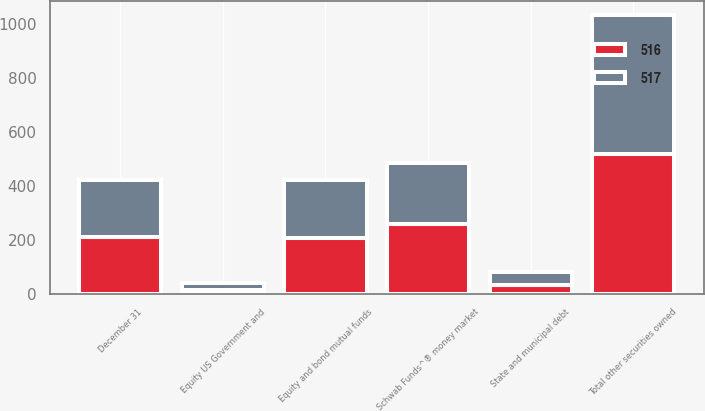<chart> <loc_0><loc_0><loc_500><loc_500><stacked_bar_chart><ecel><fcel>December 31<fcel>Schwab Funds^® money market<fcel>Equity and bond mutual funds<fcel>State and municipal debt<fcel>Equity US Government and<fcel>Total other securities owned<nl><fcel>517<fcel>211.5<fcel>224<fcel>215<fcel>51<fcel>26<fcel>516<nl><fcel>516<fcel>211.5<fcel>261<fcel>208<fcel>32<fcel>16<fcel>517<nl></chart> 